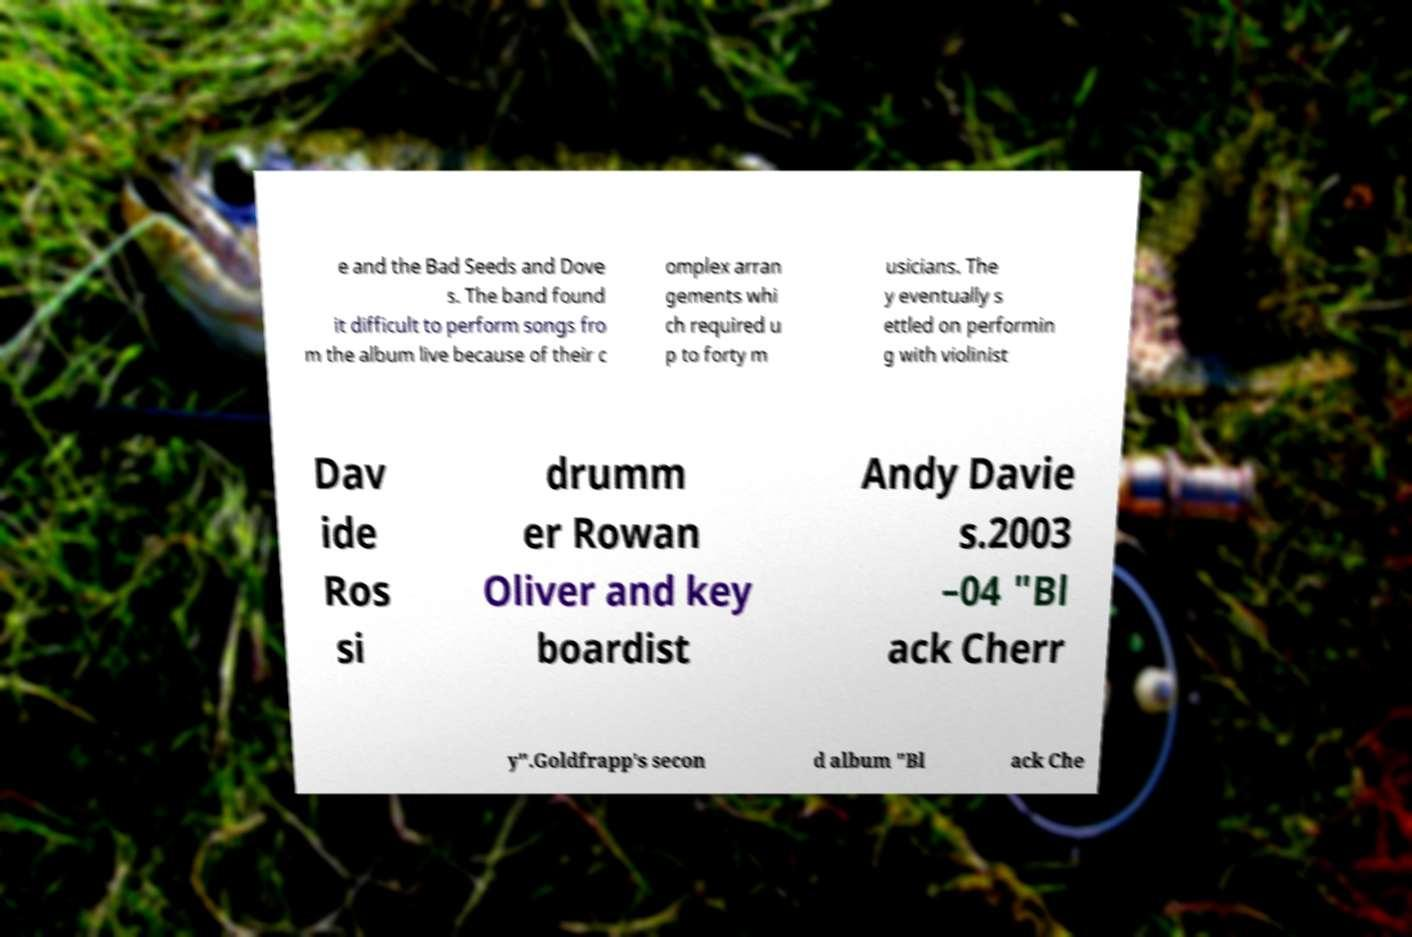Could you assist in decoding the text presented in this image and type it out clearly? e and the Bad Seeds and Dove s. The band found it difficult to perform songs fro m the album live because of their c omplex arran gements whi ch required u p to forty m usicians. The y eventually s ettled on performin g with violinist Dav ide Ros si drumm er Rowan Oliver and key boardist Andy Davie s.2003 –04 "Bl ack Cherr y".Goldfrapp's secon d album "Bl ack Che 